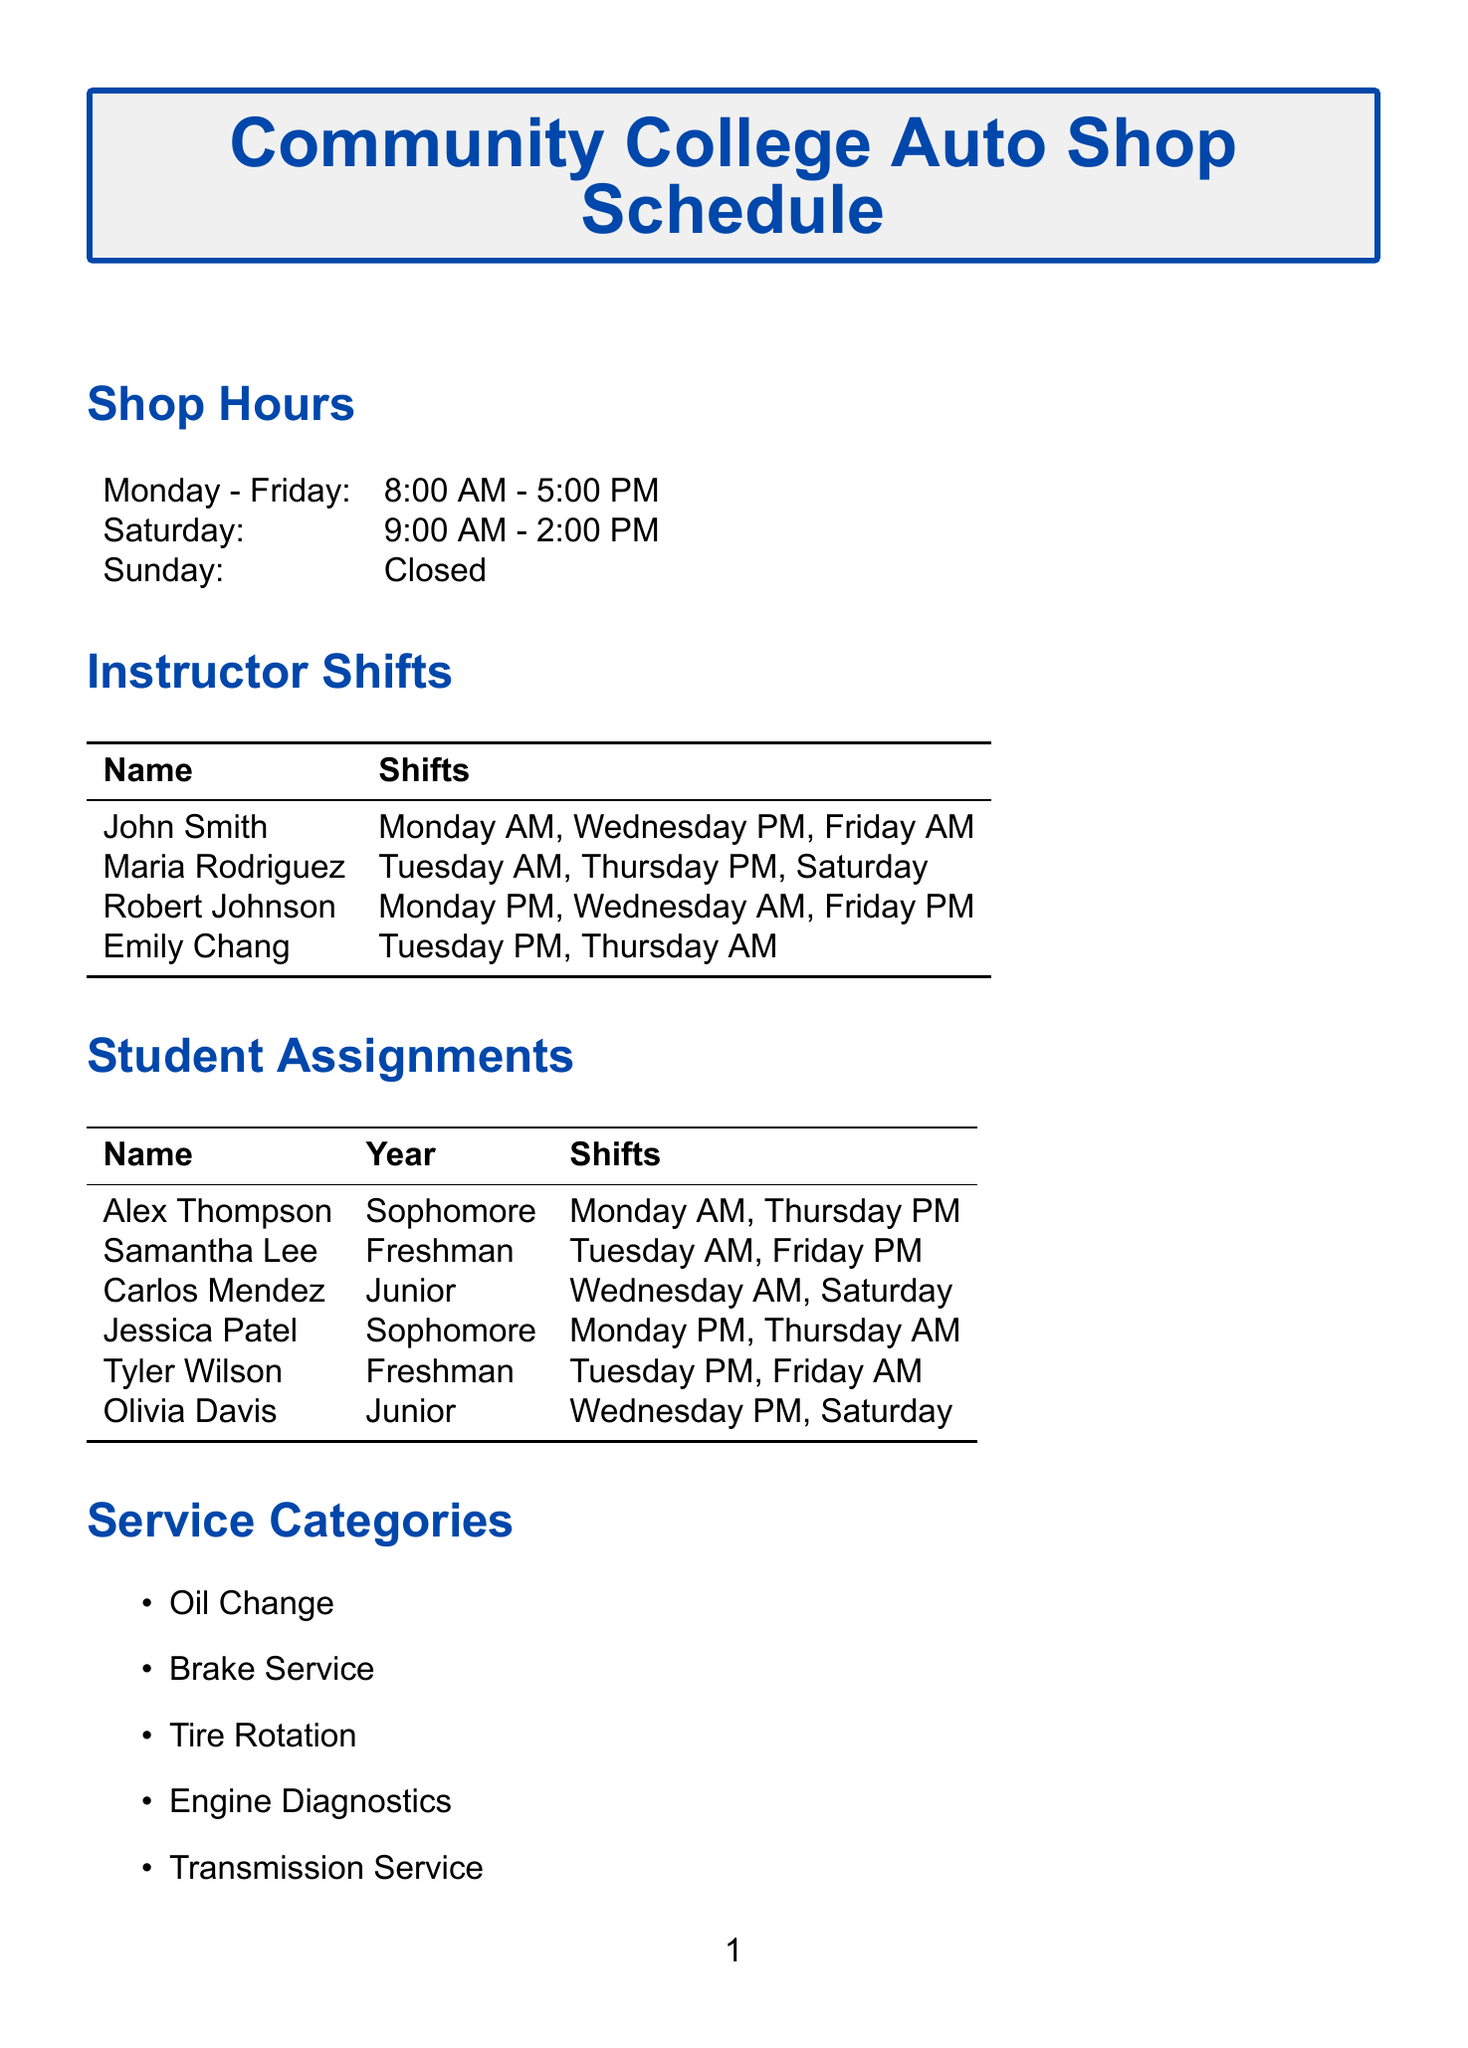What are the shop hours on Saturday? The shop hours on Saturday are listed in the document.
Answer: 9:00 AM - 2:00 PM How many instructors work on Monday? By checking the instructor shifts, we can count the instructors working on Monday.
Answer: 2 What is the last calibration date for the OBD-II Scanner? The last calibration date is found in the tools inventory section.
Answer: 2023-03-15 Which student is assigned to the Tuesday PM shift? This requires checking the student assignments for the relevant shift.
Answer: Tyler Wilson How many appointment slots are listed in the document? The appointment slots are provided in a specific section of the document.
Answer: 8 